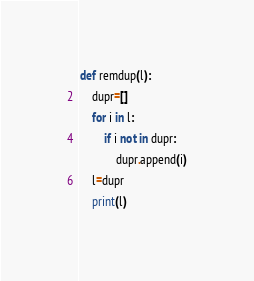<code> <loc_0><loc_0><loc_500><loc_500><_Python_>
def remdup(l):
    dupr=[]
    for i in l:
        if i not in dupr:
            dupr.append(i)
    l=dupr
    print(l)
</code> 